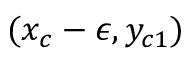Convert formula to latex. <formula><loc_0><loc_0><loc_500><loc_500>( x _ { c } - \epsilon , y _ { c 1 } )</formula> 